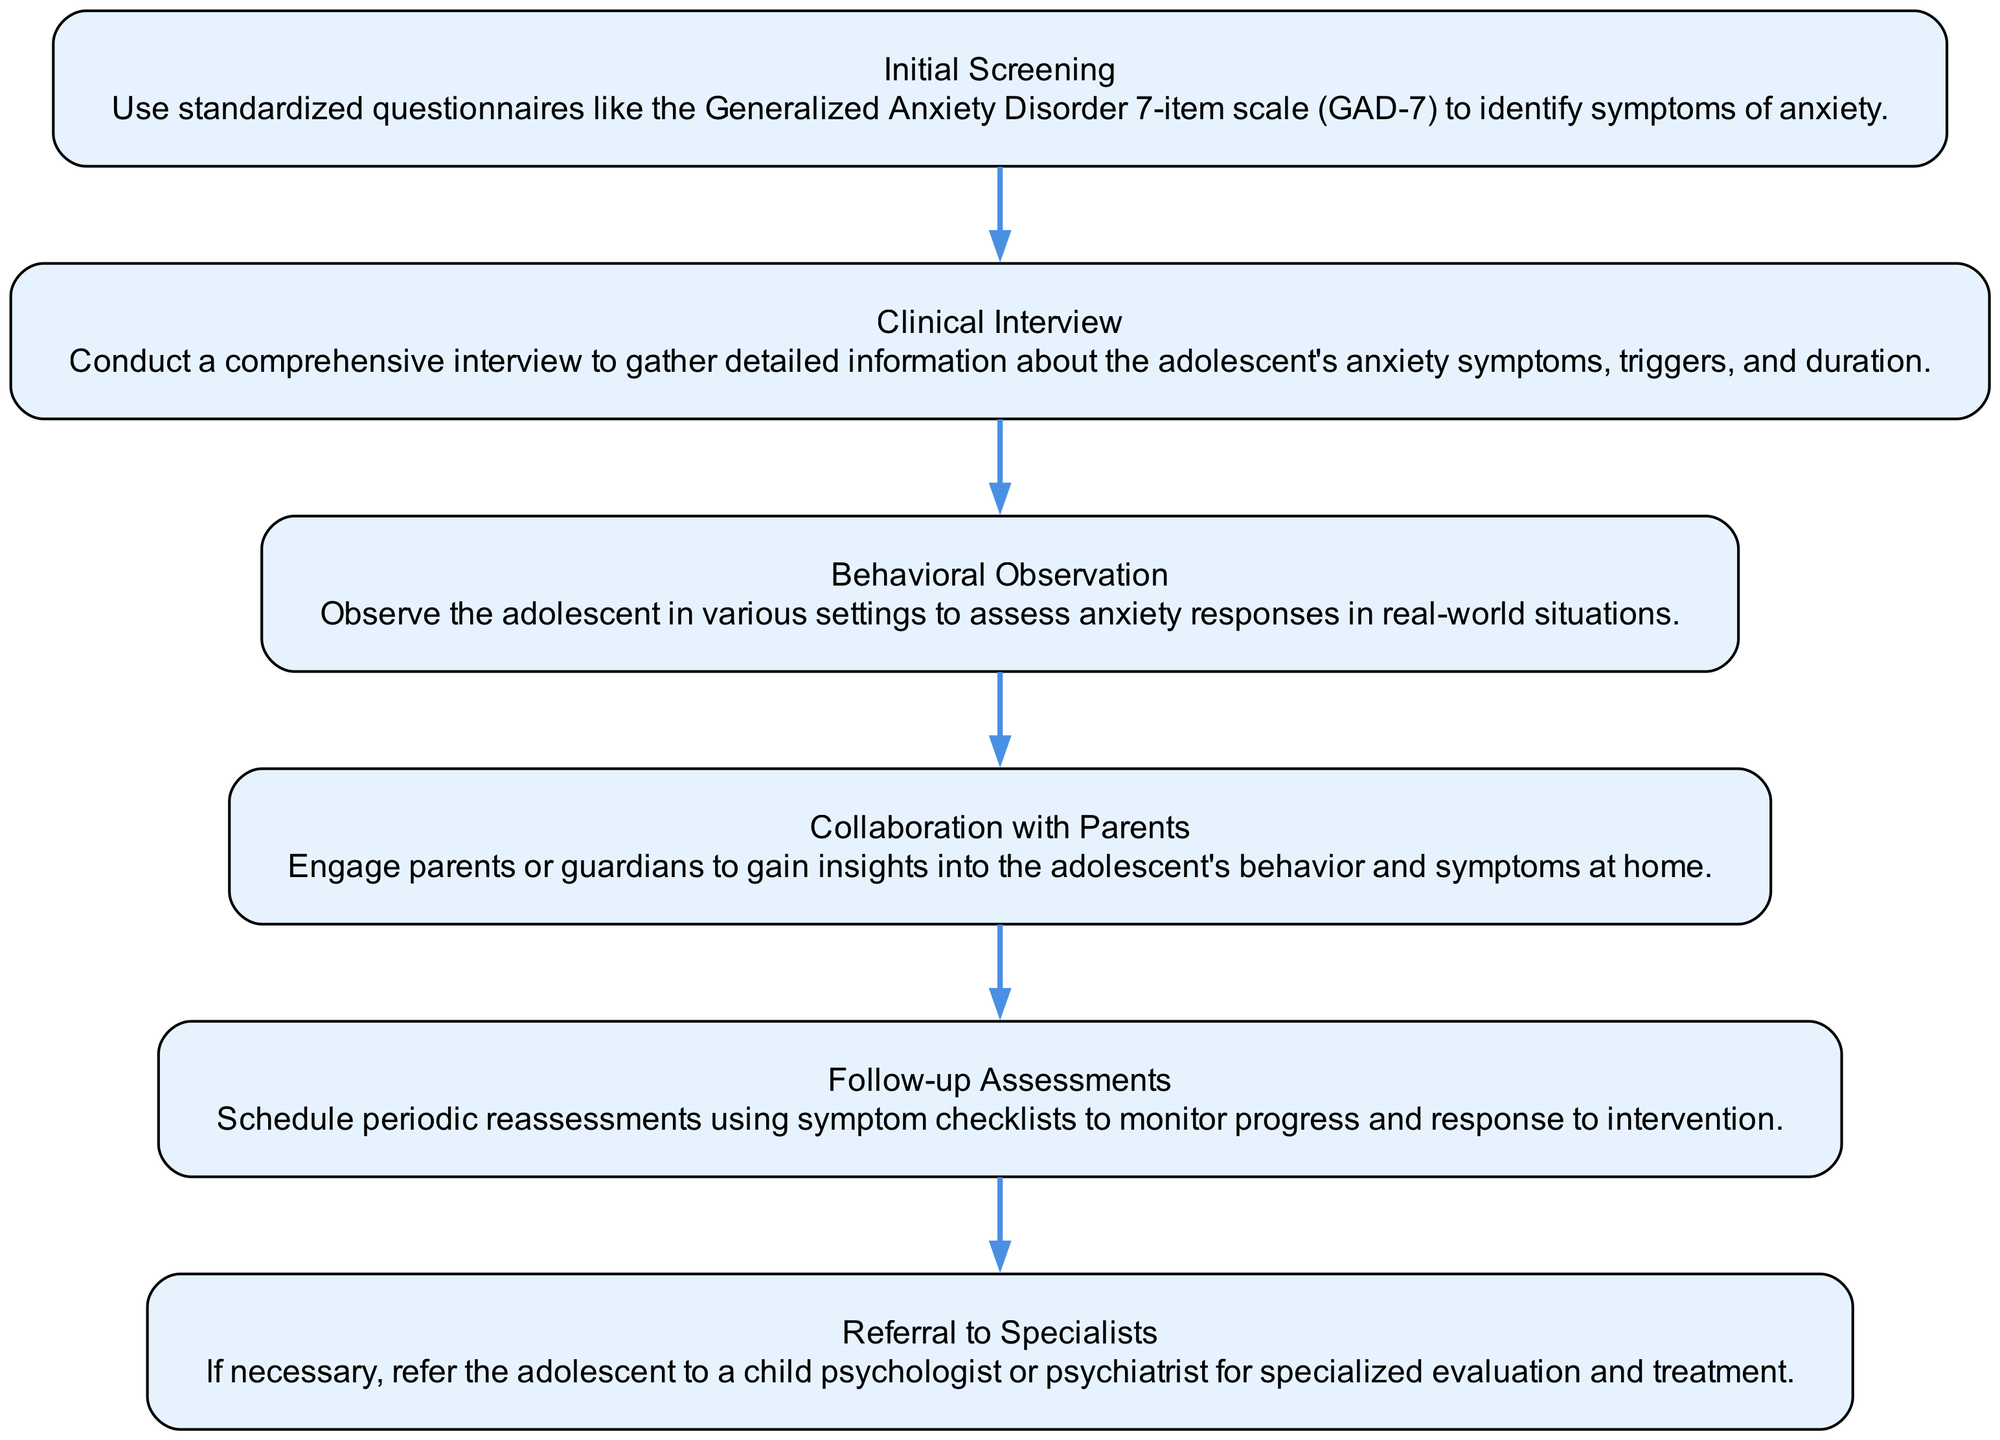What is the first step in the assessment process? The flow chart indicates that the first step in the process is the "Initial Screening," as it is the top node in the flow.
Answer: Initial Screening How many total nodes are present in the diagram? By counting the listed elements from 1 to 6, we find there are a total of 6 nodes in the assessment process flow chart.
Answer: 6 What comes after the Clinical Interview? Based on the flow of the diagram, after the "Clinical Interview" node, the next step is "Behavioral Observation."
Answer: Behavioral Observation Which step involves collaboration with parents? The flow chart clearly identifies "Collaboration with Parents" as a separate step, so that is the answer to this question as it specifically mentions working with parents in the assessment process.
Answer: Collaboration with Parents If the initial screening indicates severe anxiety, which step might follow? Following the "Initial Screening," the path continues to "Clinical Interview," which is likely to follow if the screening suggests significant symptoms, allowing for a deeper understanding of the adolescent's condition.
Answer: Clinical Interview What is the purpose of Follow-up Assessments? The flow chart lists "Follow-up Assessments," indicating that their purpose is to schedule periodic reassessments to monitor progress and response to intervention.
Answer: Monitor progress How does Behavioral Observation contribute to the assessment? "Behavioral Observation" helps in assessing anxiety responses in real-world situations, thus providing practical insights into the adolescent's anxiety beyond self-reported symptoms.
Answer: Assess anxiety responses Which step is conducted after obtaining insights from parents? After the "Collaboration with Parents" node, the flow continues to "Follow-up Assessments," indicating that these insights may inform future evaluations.
Answer: Follow-up Assessments If a referral is needed, which step is taken? The flow chart shows that the "Referral to Specialists" step is taken if, upon assessment, specialized evaluation and treatment are deemed necessary.
Answer: Referral to Specialists 